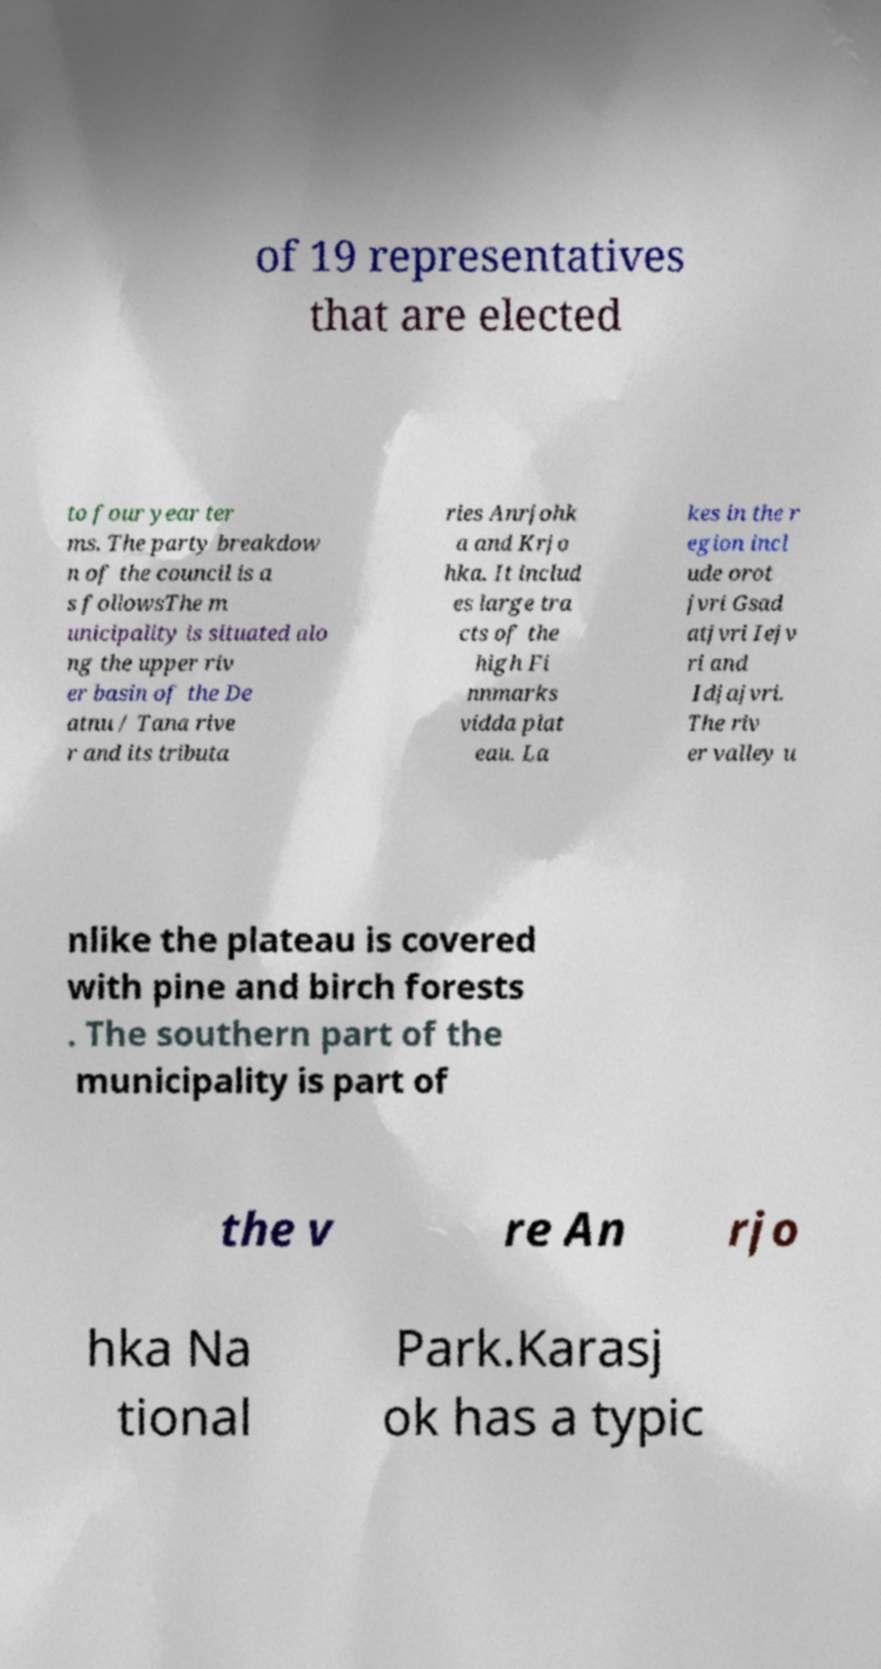Please identify and transcribe the text found in this image. of 19 representatives that are elected to four year ter ms. The party breakdow n of the council is a s followsThe m unicipality is situated alo ng the upper riv er basin of the De atnu / Tana rive r and its tributa ries Anrjohk a and Krjo hka. It includ es large tra cts of the high Fi nnmarks vidda plat eau. La kes in the r egion incl ude orot jvri Gsad atjvri Iejv ri and Idjajvri. The riv er valley u nlike the plateau is covered with pine and birch forests . The southern part of the municipality is part of the v re An rjo hka Na tional Park.Karasj ok has a typic 